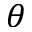Convert formula to latex. <formula><loc_0><loc_0><loc_500><loc_500>\theta</formula> 